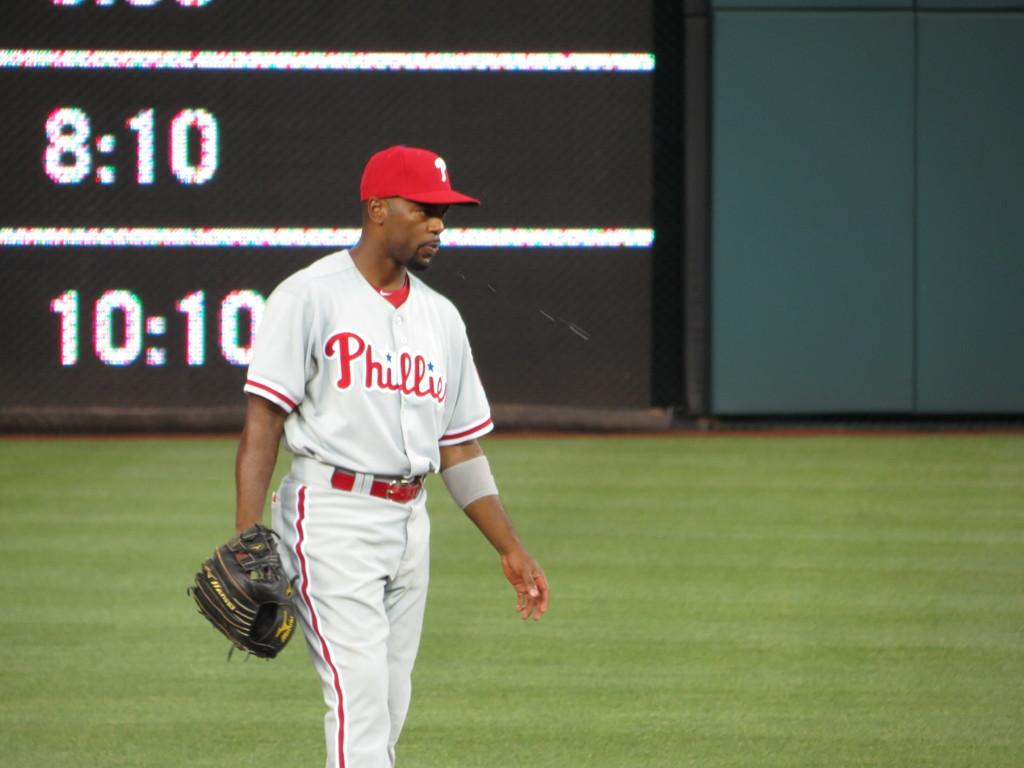Provide a one-sentence caption for the provided image. A baseball player in a Phillies jersey holds his glove in the outfield. 